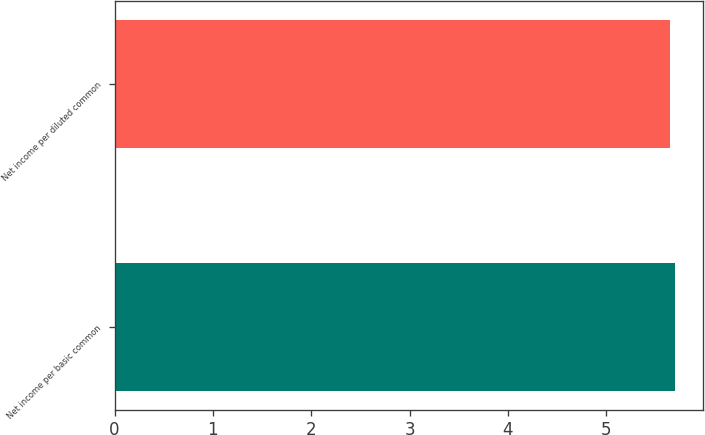Convert chart. <chart><loc_0><loc_0><loc_500><loc_500><bar_chart><fcel>Net income per basic common<fcel>Net income per diluted common<nl><fcel>5.7<fcel>5.65<nl></chart> 